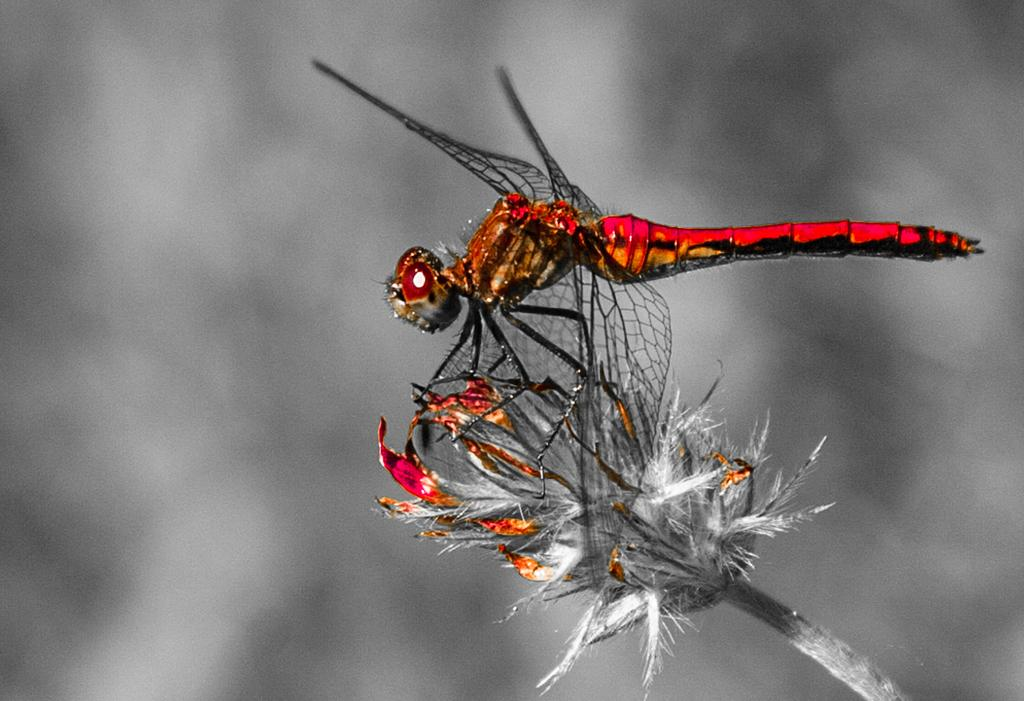What insect is sitting on a flower in the image? There is a dragonfly on a flower in the image. How is the image quality at the back? The image is blurry at the back. Has the image been altered in any way? Yes, the image is edited. Reasoning: Let'g: Let's think step by step in order to produce the conversation. We start by identifying the main subject in the image, which is the dragonfly on a flower. Then, we describe the image quality, noting that it is blurry at the back. Finally, we mention that the image has been edited, which could affect the clarity or appearance of the image. Absurd Question/Answer: What type of land can be seen in the image? There is no land visible in the image; it features a dragonfly on a flower. Is there a lake in the image? There is no lake present in the image. 